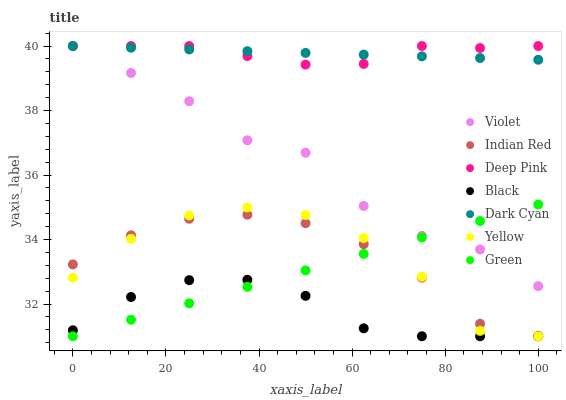Does Black have the minimum area under the curve?
Answer yes or no. Yes. Does Deep Pink have the maximum area under the curve?
Answer yes or no. Yes. Does Yellow have the minimum area under the curve?
Answer yes or no. No. Does Yellow have the maximum area under the curve?
Answer yes or no. No. Is Dark Cyan the smoothest?
Answer yes or no. Yes. Is Violet the roughest?
Answer yes or no. Yes. Is Yellow the smoothest?
Answer yes or no. No. Is Yellow the roughest?
Answer yes or no. No. Does Yellow have the lowest value?
Answer yes or no. Yes. Does Violet have the lowest value?
Answer yes or no. No. Does Dark Cyan have the highest value?
Answer yes or no. Yes. Does Yellow have the highest value?
Answer yes or no. No. Is Indian Red less than Violet?
Answer yes or no. Yes. Is Dark Cyan greater than Yellow?
Answer yes or no. Yes. Does Yellow intersect Green?
Answer yes or no. Yes. Is Yellow less than Green?
Answer yes or no. No. Is Yellow greater than Green?
Answer yes or no. No. Does Indian Red intersect Violet?
Answer yes or no. No. 